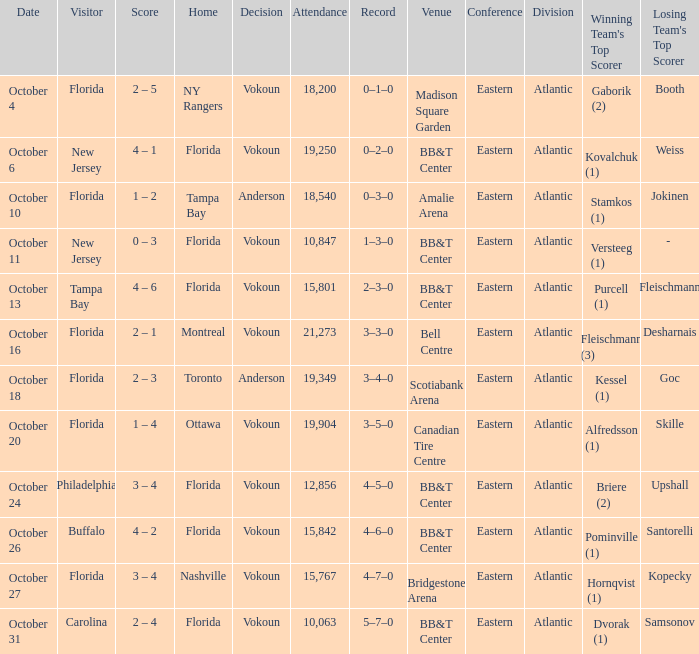What was the score on October 31? 2 – 4. 